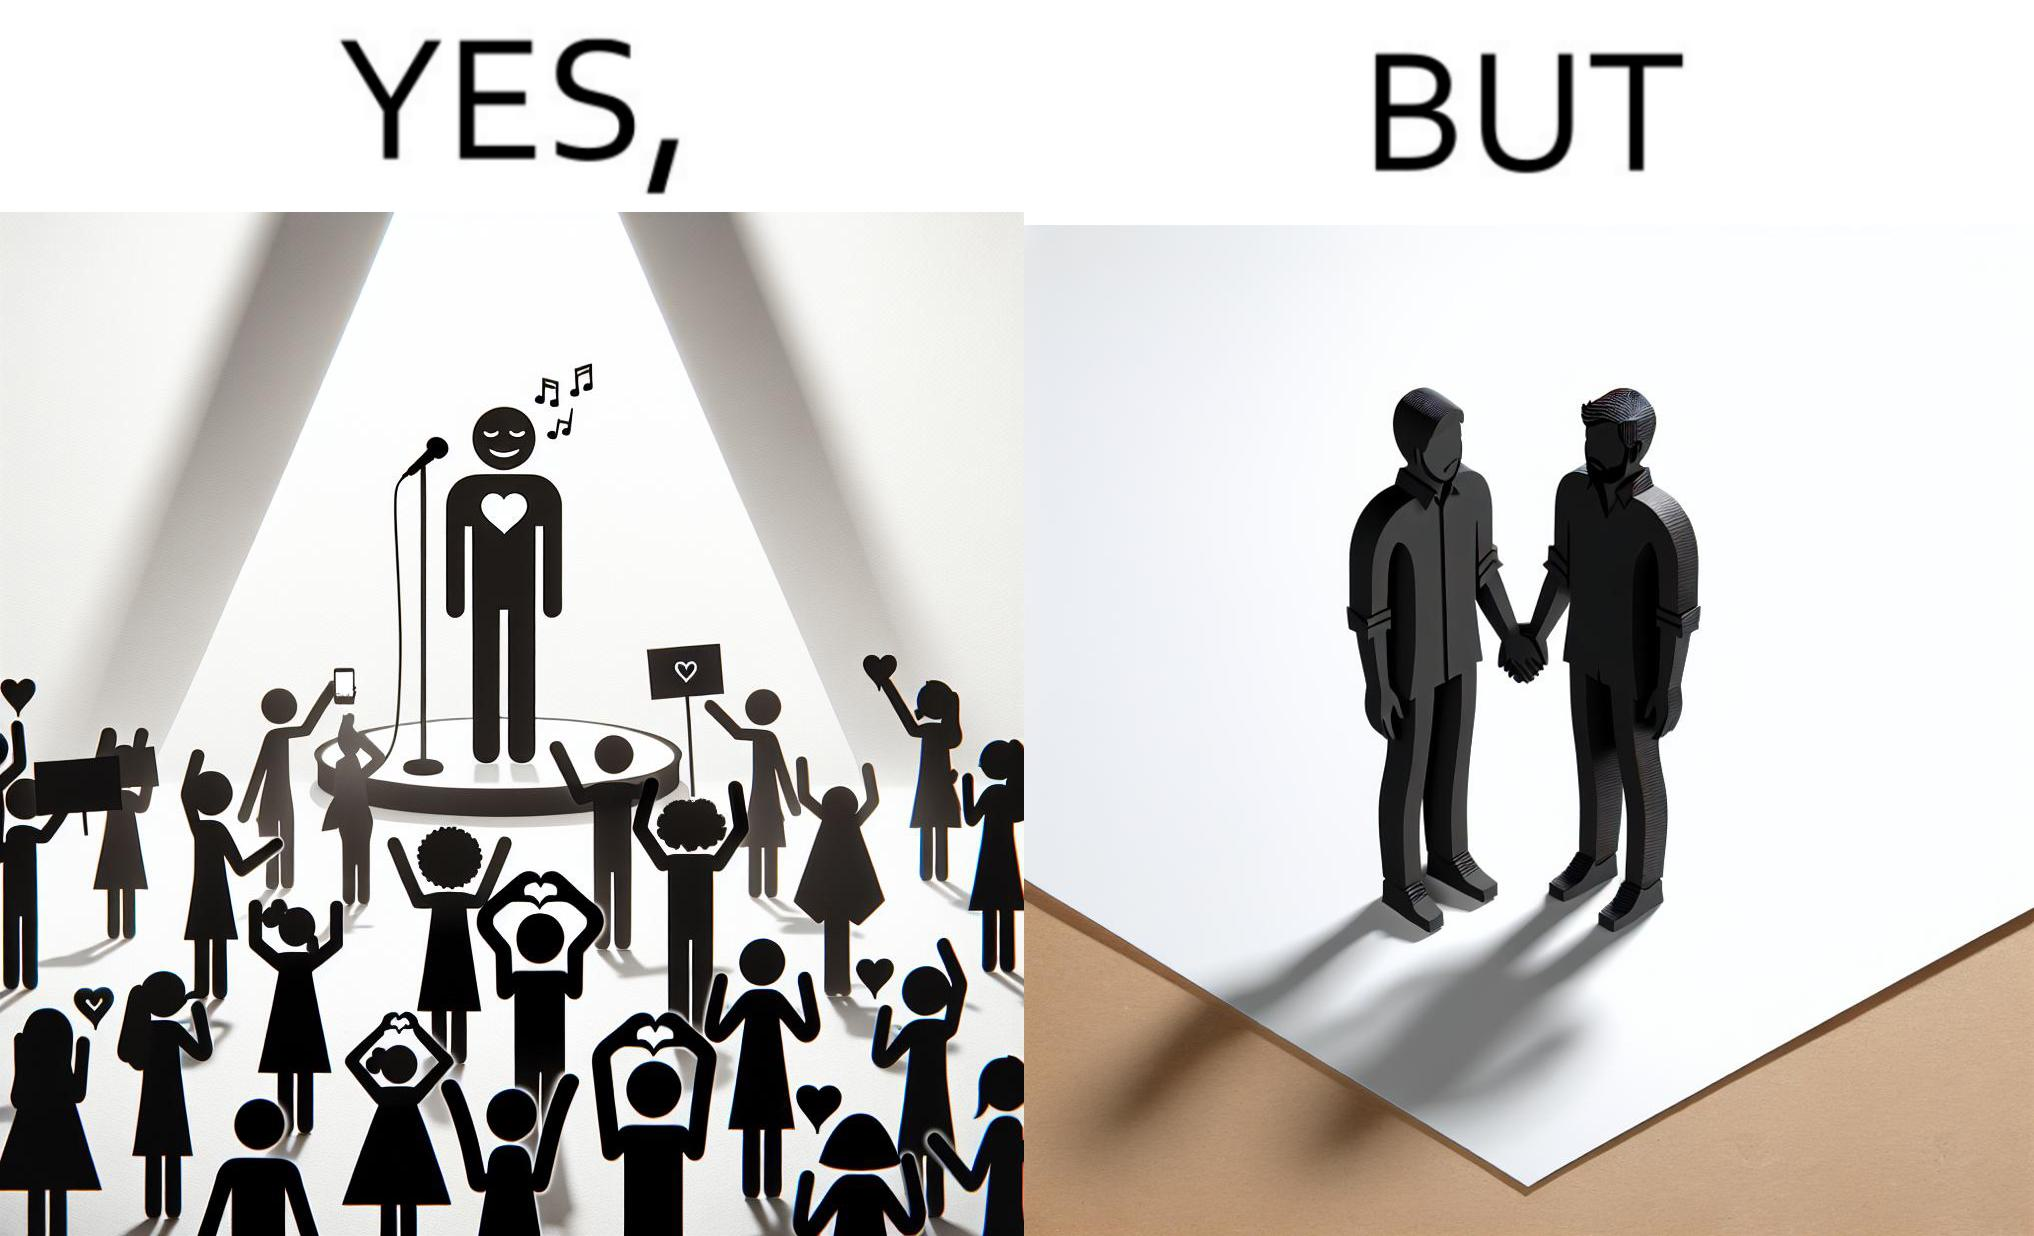Provide a description of this image. The image is funny because while the girls loves the man, he likes other men instead of women. 